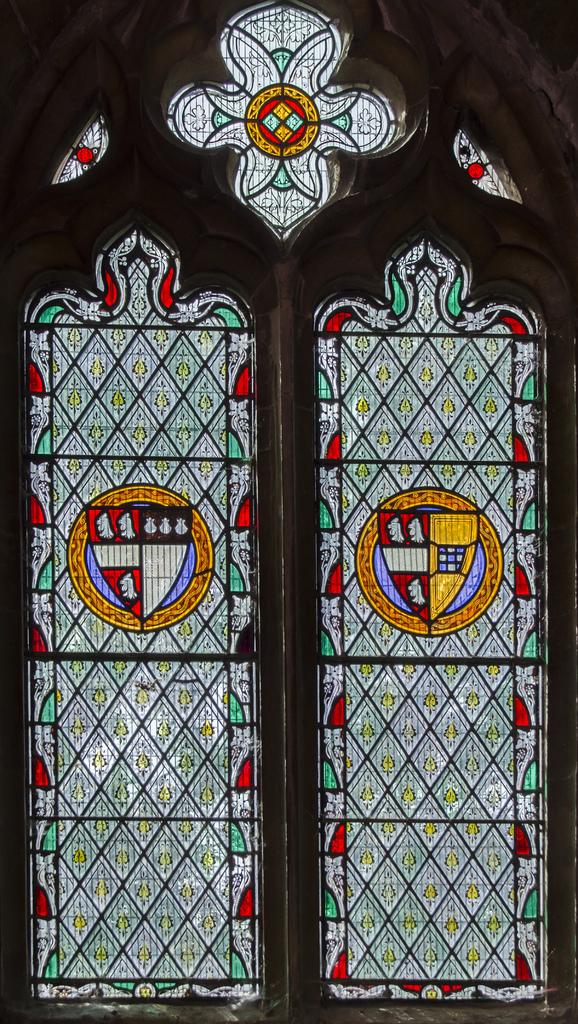What is present in the image that serves as an entrance or exit? There is a door in the image. What feature can be observed on the door? The door has stained glasses. What type of spade is being used to dig a hole in the image? There is no spade present in the image. What event is being celebrated in the image? The image does not depict any specific event, such as a birth. What action is being performed by the door in the image? The door is an inanimate object and does not perform actions like shaking. 